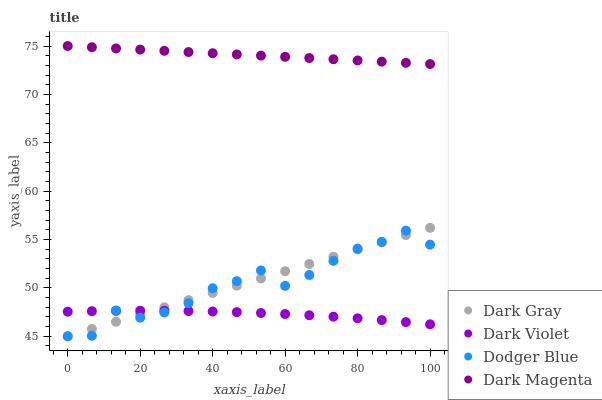Does Dark Violet have the minimum area under the curve?
Answer yes or no. Yes. Does Dark Magenta have the maximum area under the curve?
Answer yes or no. Yes. Does Dodger Blue have the minimum area under the curve?
Answer yes or no. No. Does Dodger Blue have the maximum area under the curve?
Answer yes or no. No. Is Dark Magenta the smoothest?
Answer yes or no. Yes. Is Dodger Blue the roughest?
Answer yes or no. Yes. Is Dodger Blue the smoothest?
Answer yes or no. No. Is Dark Magenta the roughest?
Answer yes or no. No. Does Dark Gray have the lowest value?
Answer yes or no. Yes. Does Dark Magenta have the lowest value?
Answer yes or no. No. Does Dark Magenta have the highest value?
Answer yes or no. Yes. Does Dodger Blue have the highest value?
Answer yes or no. No. Is Dodger Blue less than Dark Magenta?
Answer yes or no. Yes. Is Dark Magenta greater than Dodger Blue?
Answer yes or no. Yes. Does Dodger Blue intersect Dark Gray?
Answer yes or no. Yes. Is Dodger Blue less than Dark Gray?
Answer yes or no. No. Is Dodger Blue greater than Dark Gray?
Answer yes or no. No. Does Dodger Blue intersect Dark Magenta?
Answer yes or no. No. 